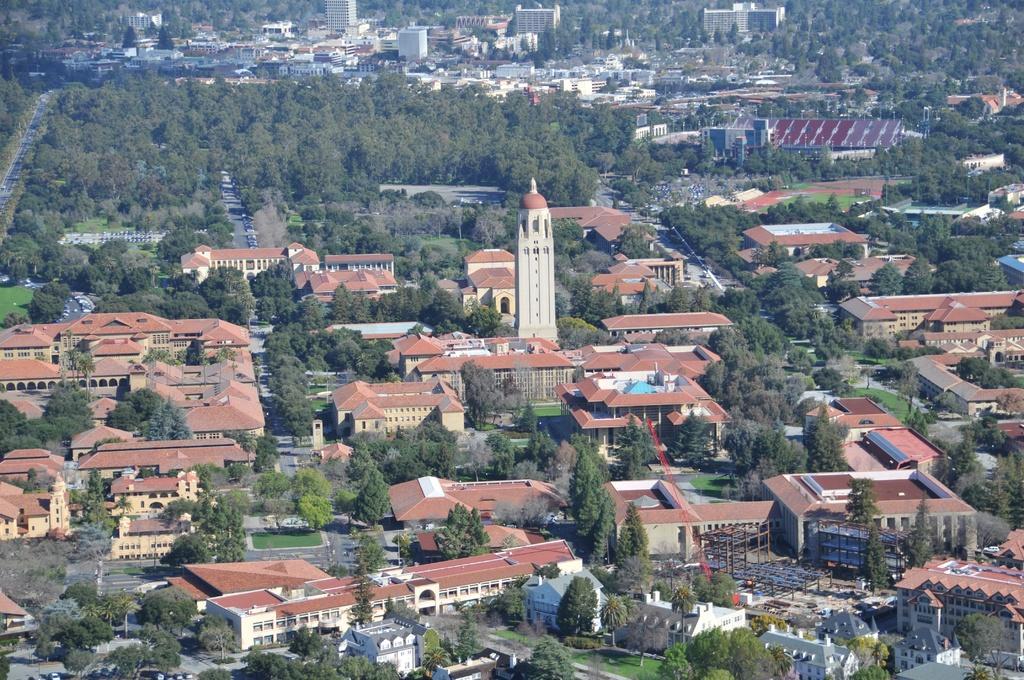How would you summarize this image in a sentence or two? In this image, we can see so many buildings, trees, roads, houses, vehicles, tower and rods. 